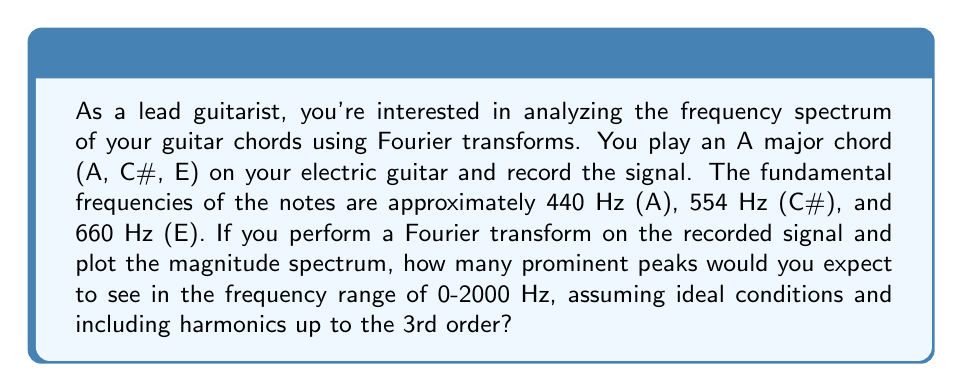Show me your answer to this math problem. To solve this problem, we need to consider the fundamental frequencies of the notes in the A major chord and their harmonics up to the 3rd order. Let's break it down step-by-step:

1. Fundamental frequencies:
   - A: 440 Hz
   - C#: 554 Hz
   - E: 660 Hz

2. Harmonics up to the 3rd order:
   For each note, we'll calculate the 2nd and 3rd harmonics using the formula:
   $$f_n = n \cdot f_1$$
   where $f_n$ is the nth harmonic and $f_1$ is the fundamental frequency.

   A:
   - 2nd harmonic: $2 \cdot 440 = 880$ Hz
   - 3rd harmonic: $3 \cdot 440 = 1320$ Hz

   C#:
   - 2nd harmonic: $2 \cdot 554 = 1108$ Hz
   - 3rd harmonic: $3 \cdot 554 = 1662$ Hz

   E:
   - 2nd harmonic: $2 \cdot 660 = 1320$ Hz
   - 3rd harmonic: $3 \cdot 660 = 1980$ Hz

3. Count the unique frequencies within the range of 0-2000 Hz:
   440, 554, 660, 880, 1108, 1320, 1662, 1980

   Note that 1320 Hz appears twice (3rd harmonic of A and 2nd harmonic of E), but we only count it once.

4. Total number of prominent peaks:
   There are 8 unique frequencies in the given range, which correspond to the prominent peaks in the magnitude spectrum of the Fourier transform.
Answer: 8 prominent peaks 